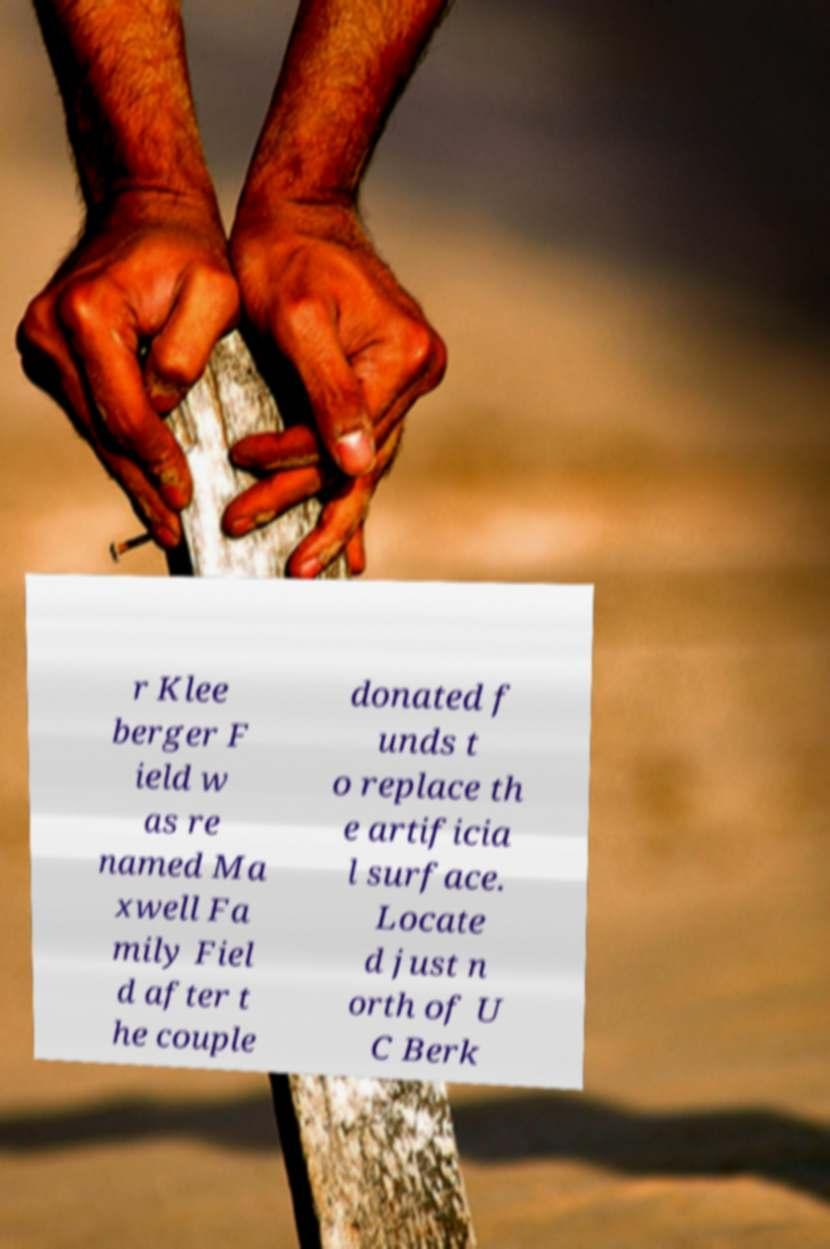Can you read and provide the text displayed in the image?This photo seems to have some interesting text. Can you extract and type it out for me? r Klee berger F ield w as re named Ma xwell Fa mily Fiel d after t he couple donated f unds t o replace th e artificia l surface. Locate d just n orth of U C Berk 